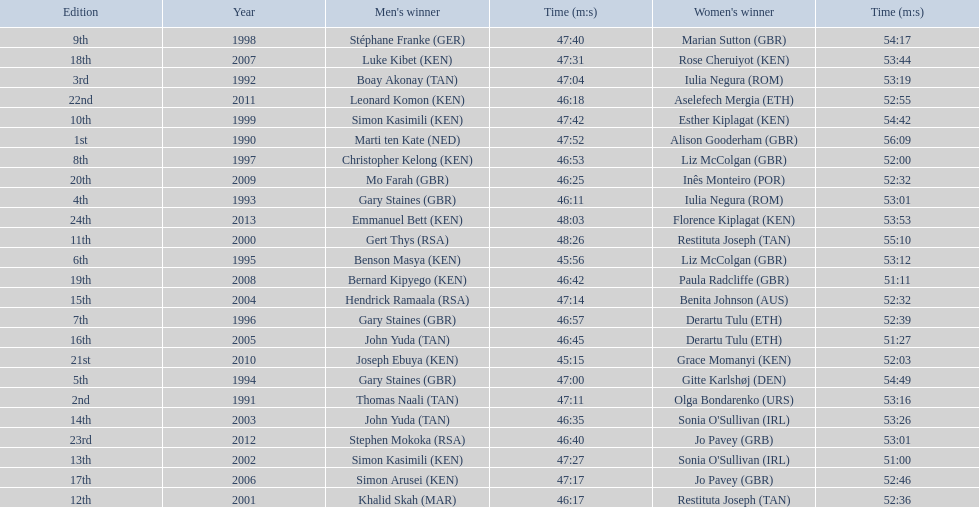Which runners are from kenya? (ken) Benson Masya (KEN), Christopher Kelong (KEN), Simon Kasimili (KEN), Simon Kasimili (KEN), Simon Arusei (KEN), Luke Kibet (KEN), Bernard Kipyego (KEN), Joseph Ebuya (KEN), Leonard Komon (KEN), Emmanuel Bett (KEN). Of these, which times are under 46 minutes? Benson Masya (KEN), Joseph Ebuya (KEN). Which of these runners had the faster time? Joseph Ebuya (KEN). 